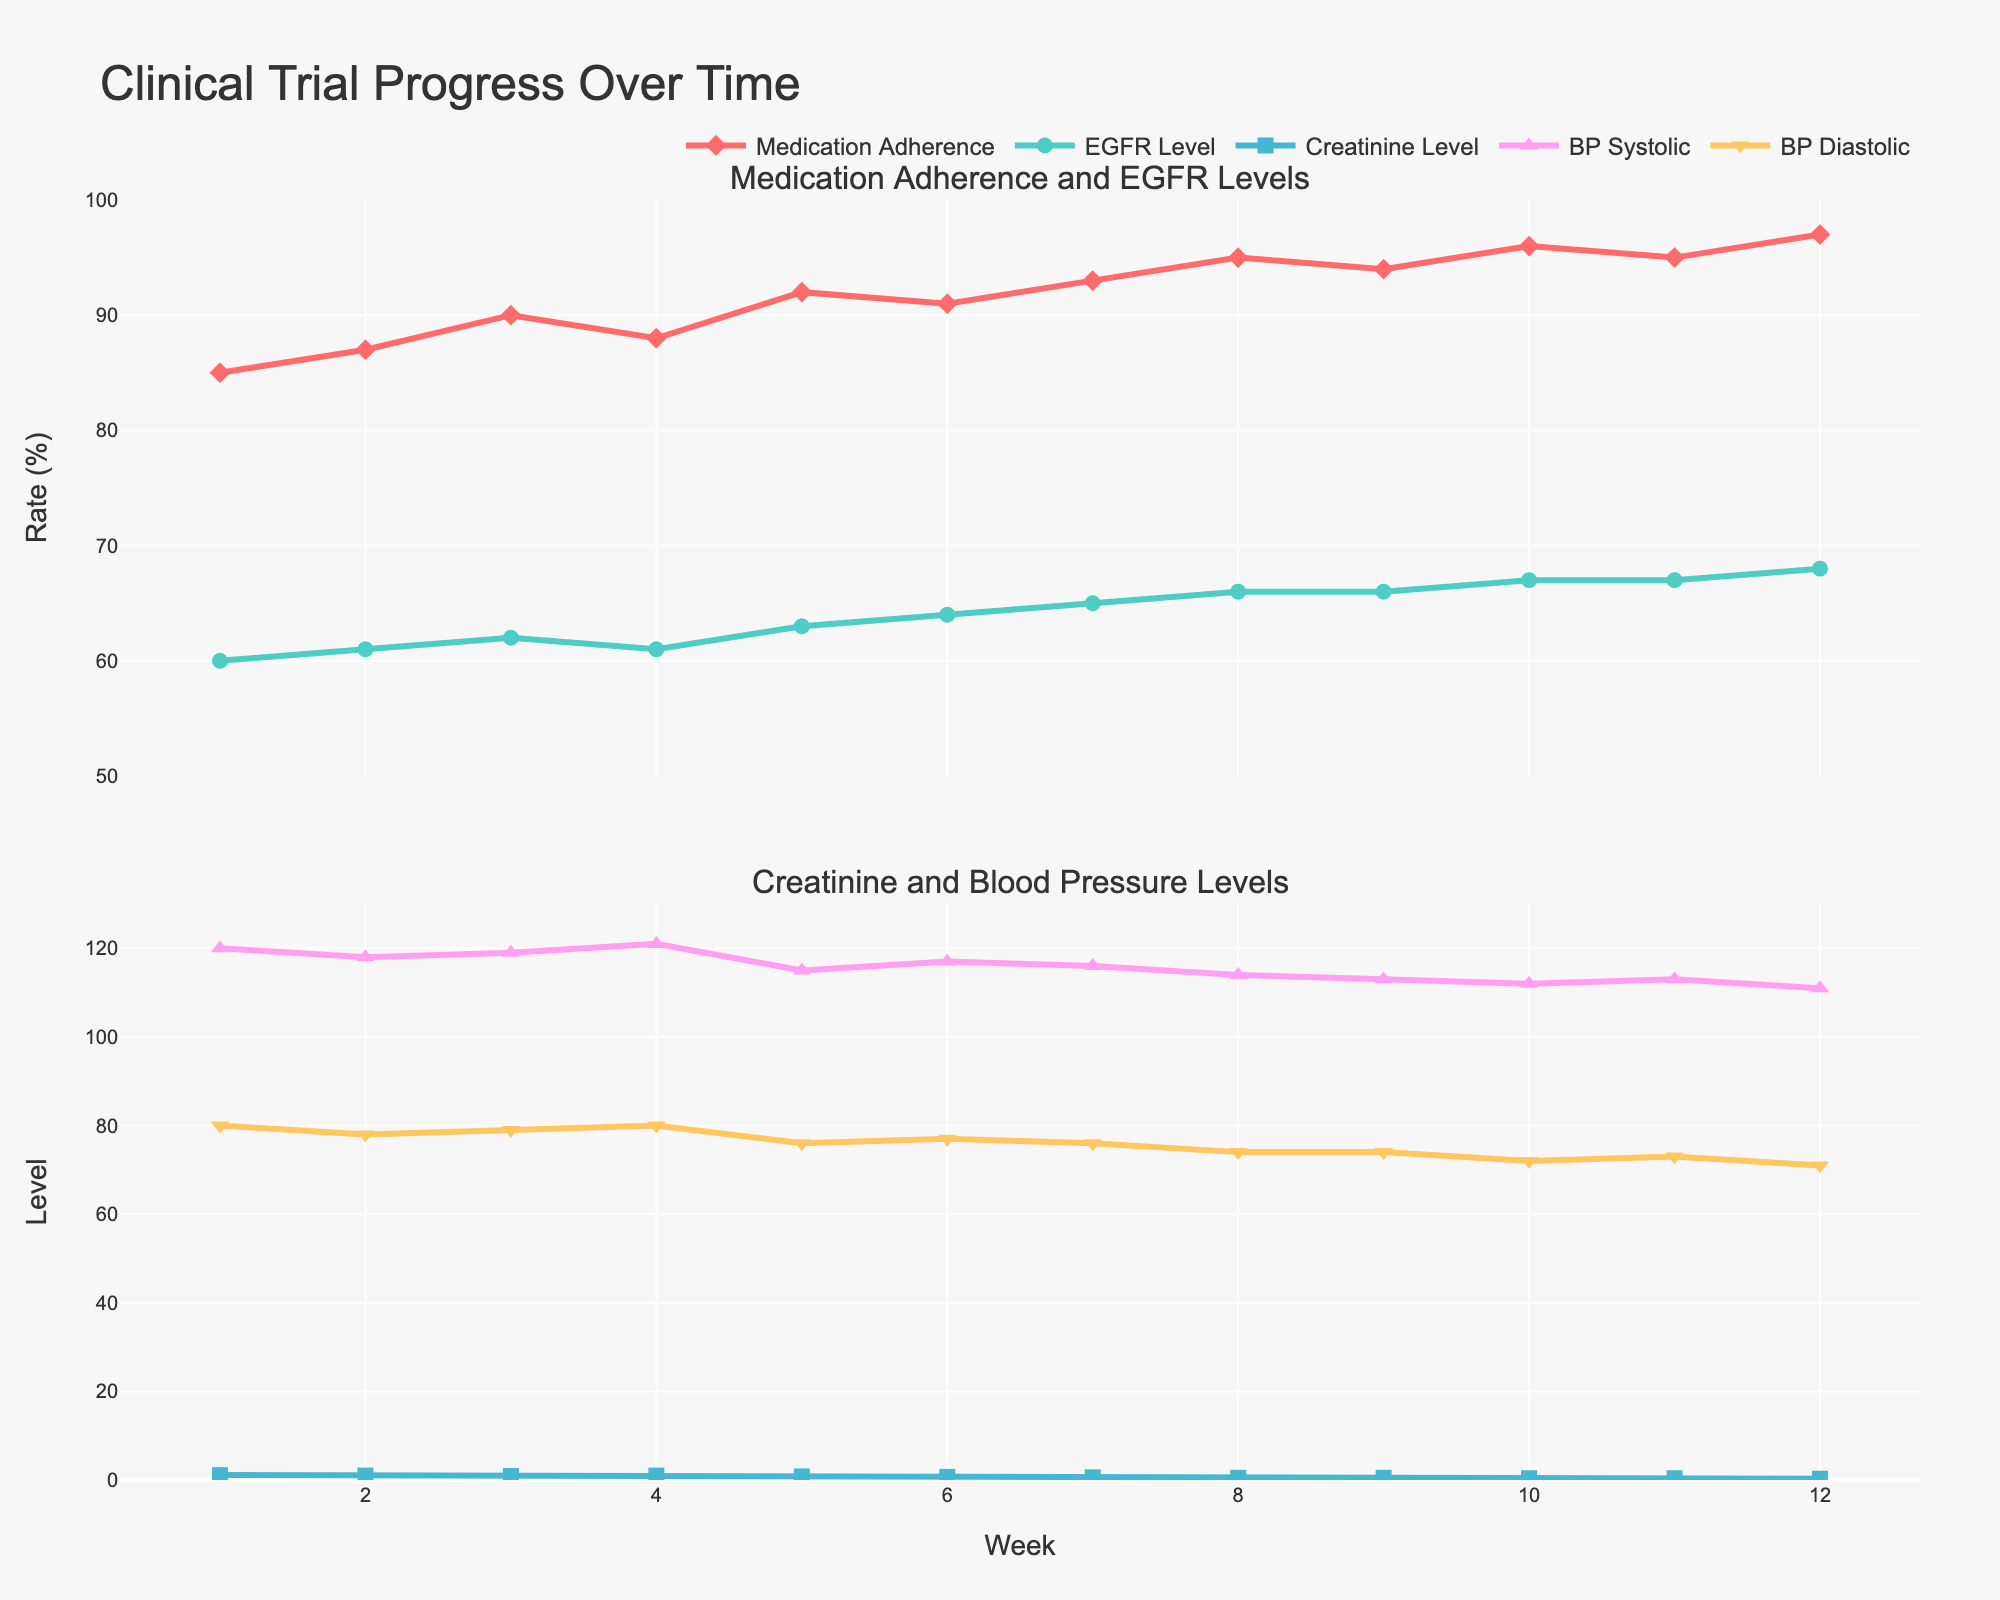How many weeks does the clinical trial cover? The x-axis of the plot representing the weeks shows that the clinical trial covers 12 weeks.
Answer: 12 What is the color of the line representing the Medication Adherence Rate? The legend in the figure indicates that the line for Medication Adherence Rate is represented in a reddish-pink color.
Answer: Reddish-pink By how much did the Medication Adherence Rate change from week 1 to week 12? The Medication Adherence Rate at week 1 is 85% and at week 12 is 97%. The change is calculated by subtracting the week 1 value from the week 12 value: 97 - 85 = 12.
Answer: 12% Which variable shows the most improvement over the trial period? By comparison, the Medication Adherence Rate increases from 85% to 97%, the EGFR Level from 60 to 68, and the Creatinine Level decreases from 1.1 to 0.3. The largest relative improvement is in Creatinine Level, which drops significantly.
Answer: Creatinine Level What is the relationship between Medication Adherence Rate and EGFR Level over the trial period? Both the Medication Adherence Rate and EGFR Level show an upward trend over the 12 weeks, indicating that as adherence improves, EGFR levels also improve. This can be seen visually where the lines for both variables rise concurrently.
Answer: Both increase How does the Blood Pressure Systolic trend compared to Diastolic over the trial period? Both Systolic and Diastolic Blood Pressure are shown in the second subplot. Systolic BP decreases from 120 to 111, while Diastolic BP decreases from 80 to 71. Systolic trends similarly to Diastolic but starts higher and ends lower.
Answer: Similar downward trend At which week did the Creatinine Level show the greatest decrease from its previous week? By examining the trend of the Creatinine Level, the largest decrease occurs between weeks 1 to 2 (1.1 to 1.0), but the most significant single week change is between week 11 to 12 from 0.4 to 0.3.
Answer: Week 12 What are the final values of Blood Pressure Systolic and Diastolic at the end of the trial? According to the plot, at week 12, Blood Pressure Systolic is 111 and Blood Pressure Diastolic is 71.
Answer: 111, 71 Which week shows the highest Medication Adherence Rate? The plot of Medication Adherence Rate peaks at week 12 with a value of 97%.
Answer: Week 12 